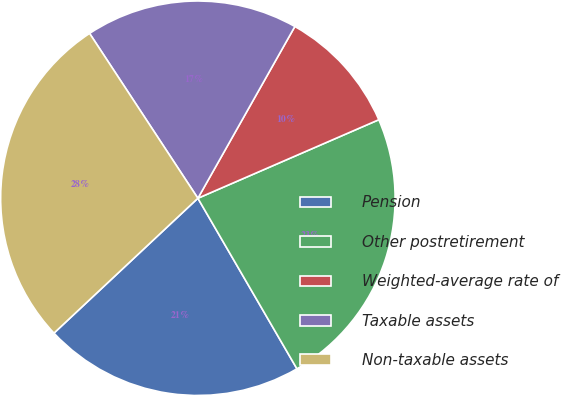Convert chart. <chart><loc_0><loc_0><loc_500><loc_500><pie_chart><fcel>Pension<fcel>Other postretirement<fcel>Weighted-average rate of<fcel>Taxable assets<fcel>Non-taxable assets<nl><fcel>21.39%<fcel>23.14%<fcel>10.3%<fcel>17.43%<fcel>27.73%<nl></chart> 